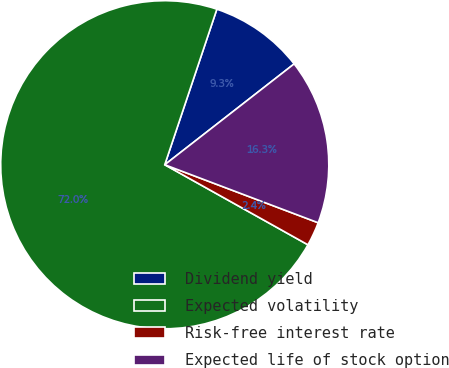Convert chart. <chart><loc_0><loc_0><loc_500><loc_500><pie_chart><fcel>Dividend yield<fcel>Expected volatility<fcel>Risk-free interest rate<fcel>Expected life of stock option<nl><fcel>9.32%<fcel>72.03%<fcel>2.36%<fcel>16.29%<nl></chart> 